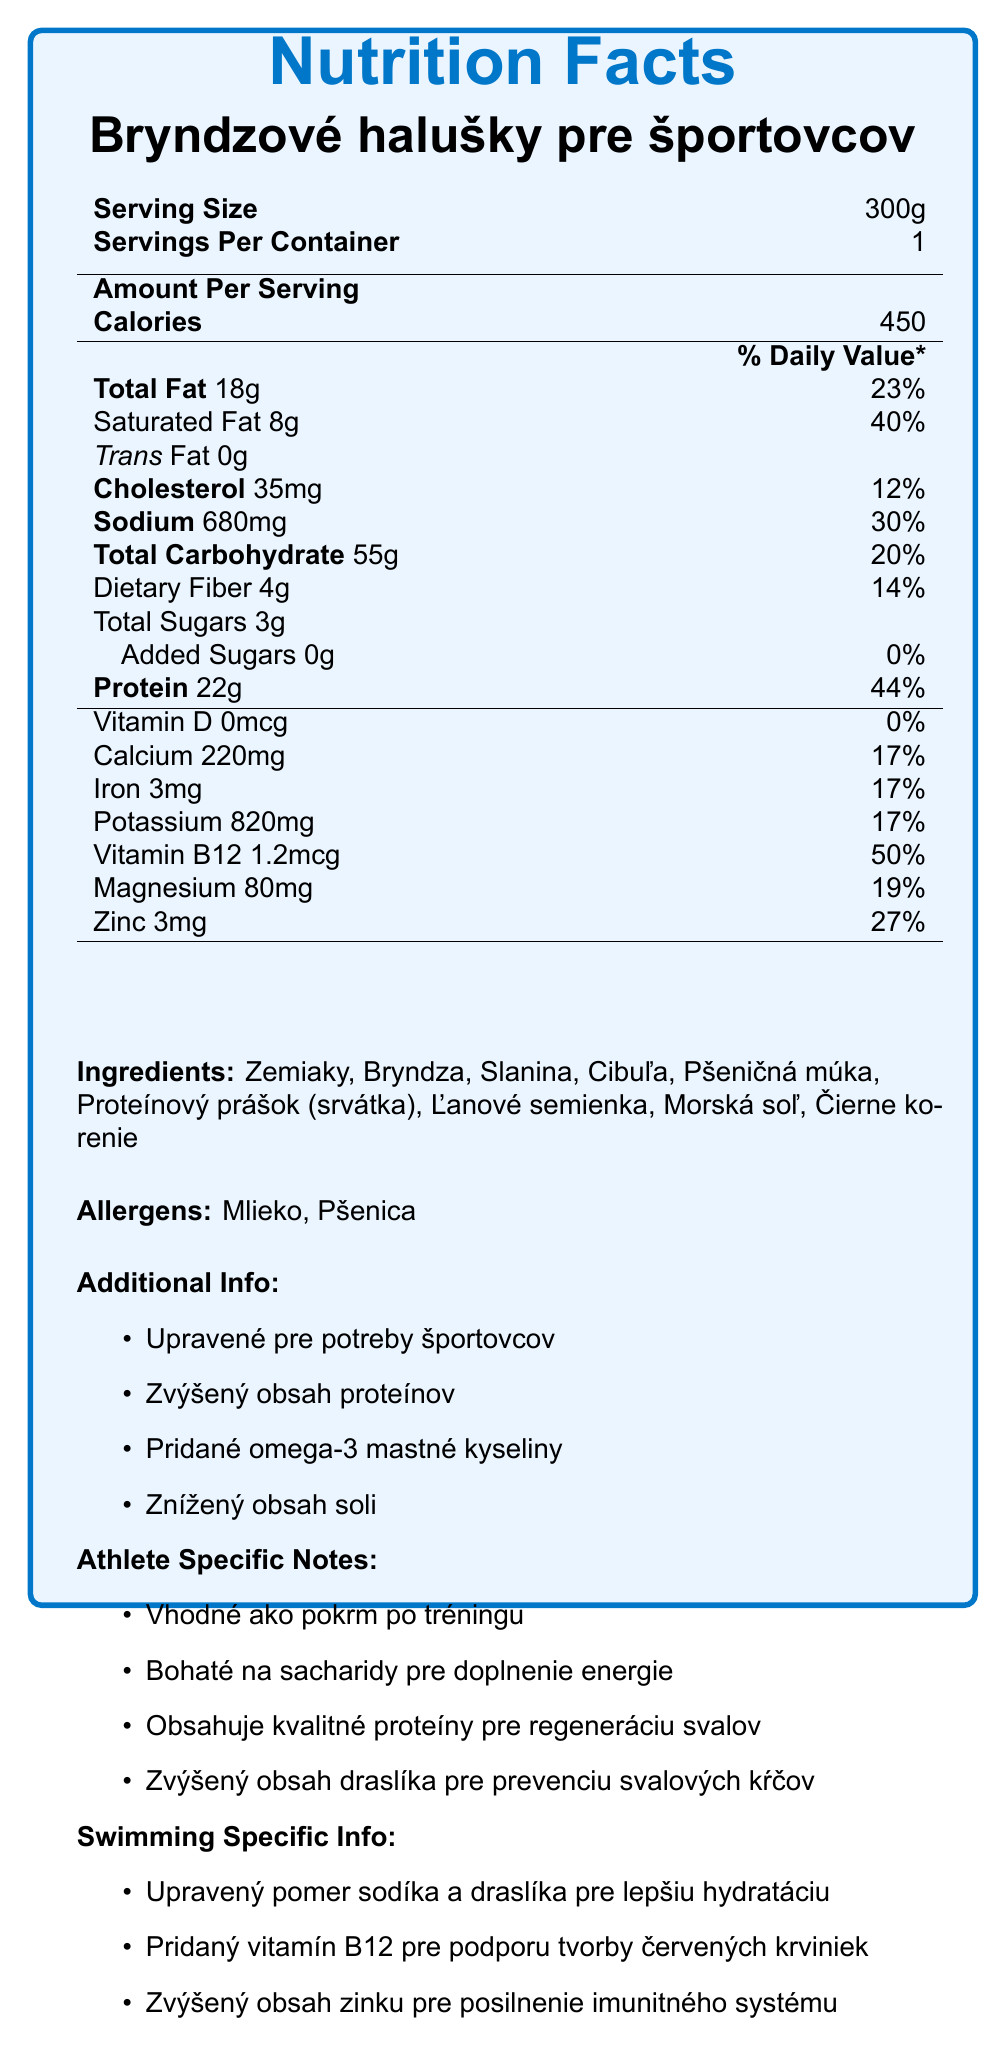what is the serving size for "Bryndzové halušky pre športovcov"? The serving size for "Bryndzové halušky pre športovcov" is listed as 300g on the nutrition facts label.
Answer: 300g How many calories are there per serving? According to the nutrition facts label, there are 450 calories per serving.
Answer: 450 What percentage of the daily value of protein does one serving of "Bryndzové halušky pre športovcov" provide? The label indicates that one serving provides 44% of the daily value for protein.
Answer: 44% Which vitamin has the highest daily value percentage in this dish? The label states that Vitamin B12 has a daily value percentage of 50%, which is the highest among the listed vitamins and minerals.
Answer: Vitamin B12 What are the two primary allergens listed? The allergens section lists "Mlieko" and "Pšenica", which translate to "Milk" and "Wheat".
Answer: Mlieko, Pšenica (Milk, Wheat) Which of the following ingredients can be found in the dish? (A) Rice (B) Potatoes (C) Chicken (D) Fish Potatoes are listed among the ingredients, while the other options are not.
Answer: B What is the amount of dietary fiber per serving? (A) 2g (B) 3g (C) 4g (D) 5g The nutrition facts label states that there are 4g of dietary fiber per serving.
Answer: C Does the dish contain any trans fat? The label indicates that there is 0g of trans fat per serving.
Answer: No Summarize the benefits of this meal for athletes. The meal is described as suitable for consumption after training, providing necessary carbohydrates for energy replenishment. It also contains high-quality protein which helps in muscle recovery and has a higher potassium content to prevent muscle cramps.
Answer: Suitable post-training meal, rich in carbohydrates for energy replenishment, contains high-quality protein for muscle recovery, higher potassium content to prevent muscle cramps. What are the main nutritional adaptations for swimming specifically? The label mentions adjustments specifically for swimming, including an adjusted sodium and potassium ratio for better hydration, added Vitamin B12 to support red blood cell production, and increased zinc to boost the immune system.
Answer: Adjusted sodium and potassium ratio for better hydration, added Vitamin B12 for red blood cell support, increased zinc for immune system support. How does the sodium content compare to the daily value percentage for this nutrient? The sodium content in one serving is 680mg, which corresponds to 30% of the daily value.
Answer: It provides 30% of the daily value. What is the main idea of the document? This document encompasses various aspects of the meal, including detailed nutritional values, modifications made for athletic purposes, specific advantages for swimmers, and information on ingredients and allergens.
Answer: The document provides the nutritional information, ingredient list, allergen information, and specific benefits of a traditional Slovak meal adapted for athletes' needs, with a special focus on swimming. What is the source of omega-3 fatty acids in this meal? The document mentions that omega-3 fatty acids are added, but it does not specify the source of these omega-3 fatty acids.
Answer: Cannot be determined 